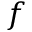<formula> <loc_0><loc_0><loc_500><loc_500>f</formula> 